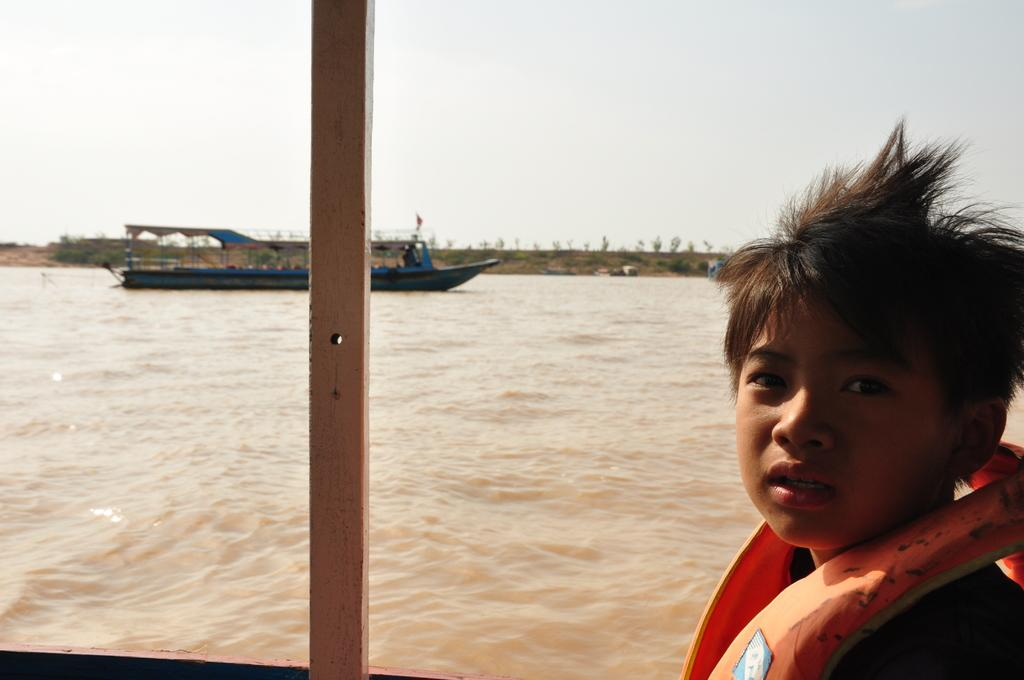Who is the main subject in the image? There is a boy standing at the bottom of the image. What is the boy doing in the image? The boy is watching something in the image. What is located behind the boy? There is water behind the boy. What can be seen above the water in the image? There is a ship above the water. What is visible at the top of the image? The sky is visible at the top of the image. What advice does the owl give to the boy in the image? There is no owl present in the image, so no advice can be given. 